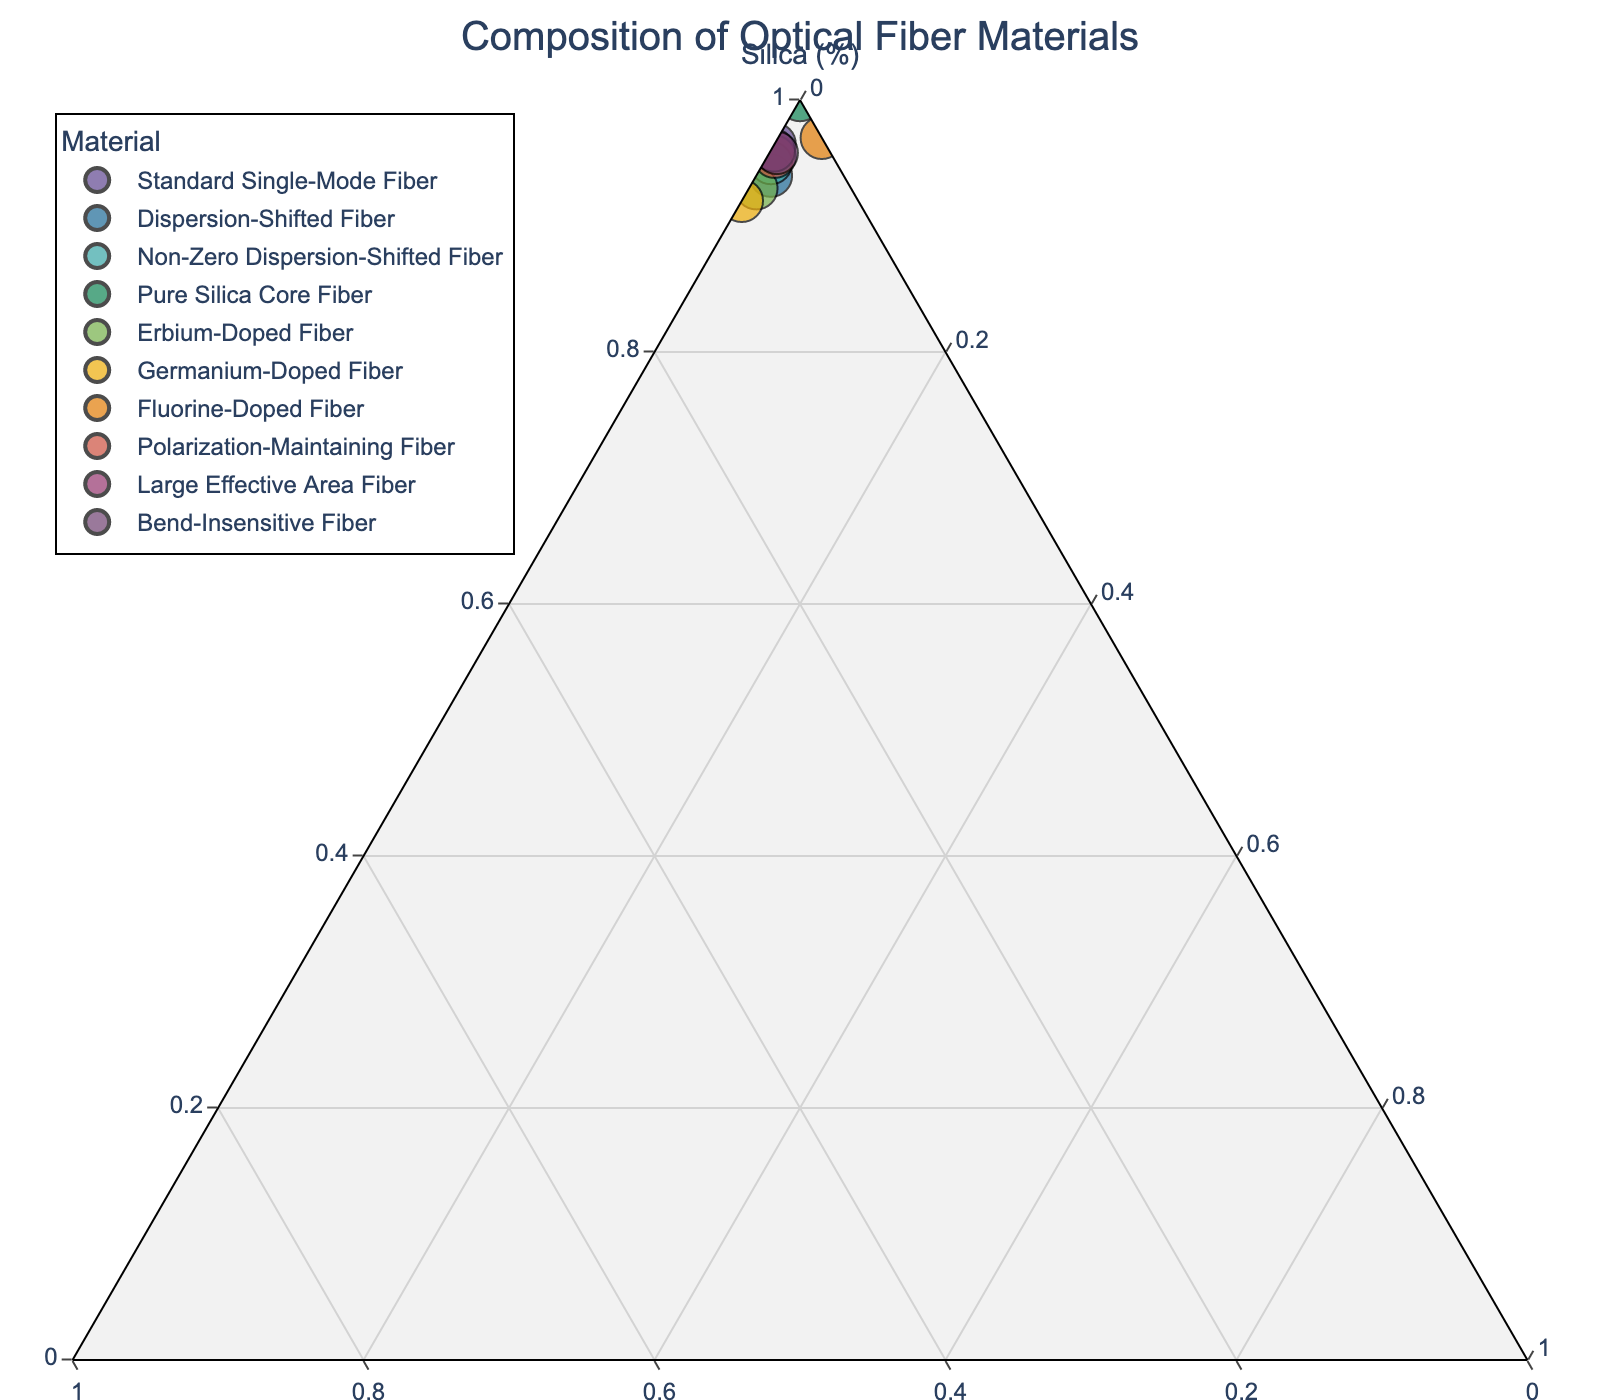Which material has the highest Silica composition? From the ternary plot, "Pure Silica Core Fiber" is located at the apex of the Silica axis, representing 100% Silica composition.
Answer: Pure Silica Core Fiber Which material is closest to having equal parts of Silica, Germania, and Fluorine? Examine the plot for points near the center of the ternary plot, where equal parts would be located. None of the materials have a composition near the center, indicating none are close to having equal parts of each component.
Answer: None How many materials contain Fluorine in their composition? Look at the plot and identify the data points that have a significant c-component value (Fluorine). Four materials contain Fluorine: "Dispersion-Shifted Fiber," "Non-Zero Dispersion-Shifted Fiber," "Erbium-Doped Fiber," and "Fluorine-Doped Fiber."
Answer: Four Which material shows the highest composition of Germania? Identify the point with the highest b-component value (Germania). "Germanium-Doped Fiber" has the highest Germania composition at approximately 8%.
Answer: Germanium-Doped Fiber Are there any fibers that have 0% Germania? If so, which ones? Locate the points where the b-component (Germania) is 0. The fibers with 0% Germania are "Pure Silica Core Fiber" and "Fluorine-Doped Fiber."
Answer: Pure Silica Core Fiber, Fluorine-Doped Fiber Compare the composition of "Dispersion-Shifted Fiber" and "Large Effective Area Fiber." Which has more Germania? From the plot, "Dispersion-Shifted Fiber" has about 5% Germania, while "Large Effective Area Fiber" has about 3.8% Germania.
Answer: Dispersion-Shifted Fiber Which material has the lowest Fluorine percentage among those that do contain Fluorine? Among the materials containing Fluorine ("Dispersion-Shifted Fiber," "Non-Zero Dispersion-Shifted Fiber," "Erbium-Doped Fiber," "Fluorine-Doped Fiber"), "Large Effective Area Fiber" has the lowest Fluorine percentage at 0.2%.
Answer: Large Effective Area Fiber What's the combined percentage of Germania and Fluorine in "Erbium-Doped Fiber"? Sum the percentages of Germania (6.5%) and Fluorine (0.5%) for "Erbium-Doped Fiber." 6.5 + 0.5 = 7%
Answer: 7% How does the composition of "Standard Single-Mode Fiber" compare with "Bend-Insensitive Fiber" in terms of Silica and Germania? Compare their positions along the a-axis (Silica) and b-axis (Germania). "Standard Single-Mode Fiber" has 96.5% Silica and 3.5% Germania, while "Bend-Insensitive Fiber" has 95.8% Silica and 3.7% Germania.
Answer: "Standard Single-Mode Fiber" has more Silica, "Bend-Insensitive Fiber" has more Germania Identify the material with subtle changes to its composition by considering both Silica and Fluorine. Check the materials with slight changes in Silica and Fluorine. "Large Effective Area Fiber" is such a material with 96% Silica and 0.2% Fluorine.
Answer: Large Effective Area Fiber 